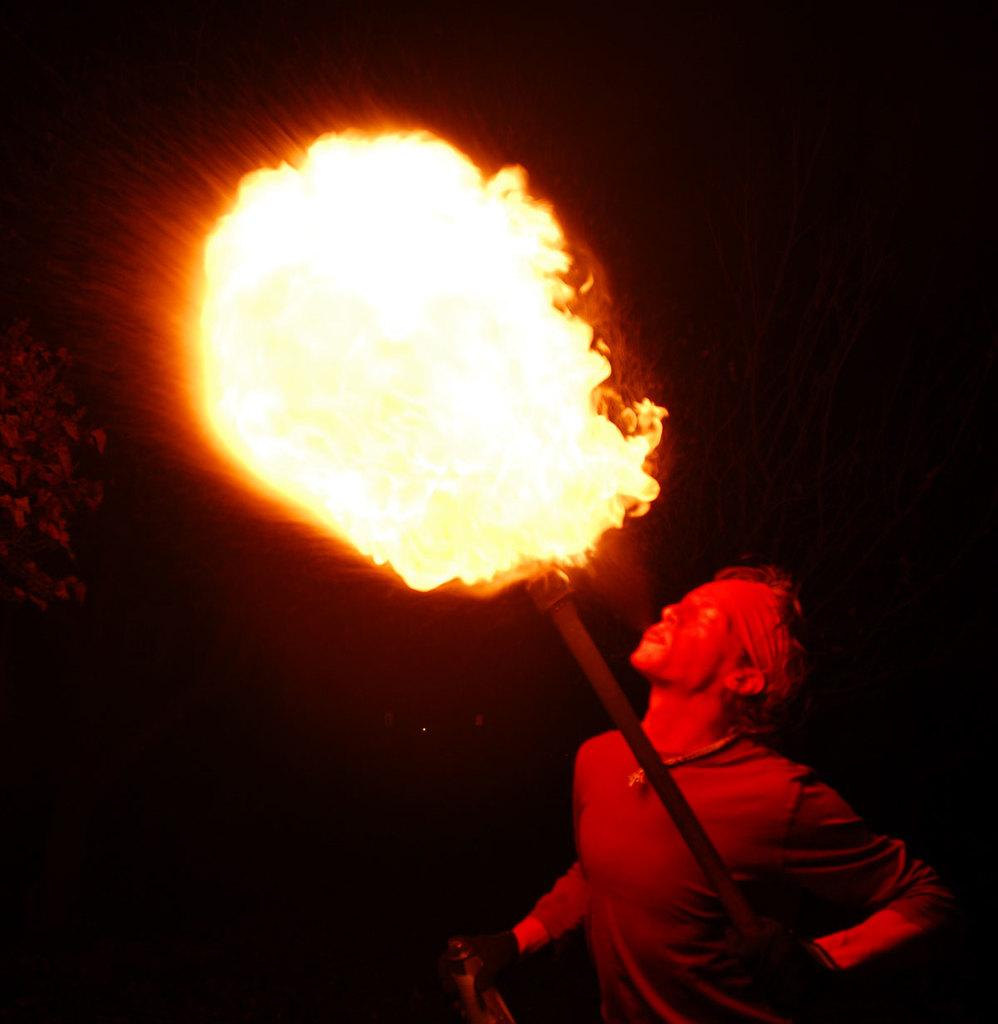What is the main subject of the image? There is a man in the image. What is the man doing in the image? The man is standing and holding a stick with a fire. How is the man interacting with the fire? The man is blowing the fire. What can be inferred about the environment in the image? The image is set in a dark environment. What type of tax is the man paying in the image? There is no indication of any tax being paid in the image; the man is holding a stick with a fire and blowing it. 